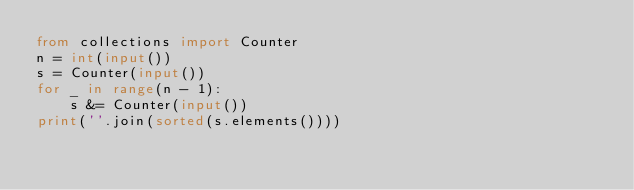Convert code to text. <code><loc_0><loc_0><loc_500><loc_500><_Python_>from collections import Counter
n = int(input())
s = Counter(input())
for _ in range(n - 1):
    s &= Counter(input())
print(''.join(sorted(s.elements())))
</code> 